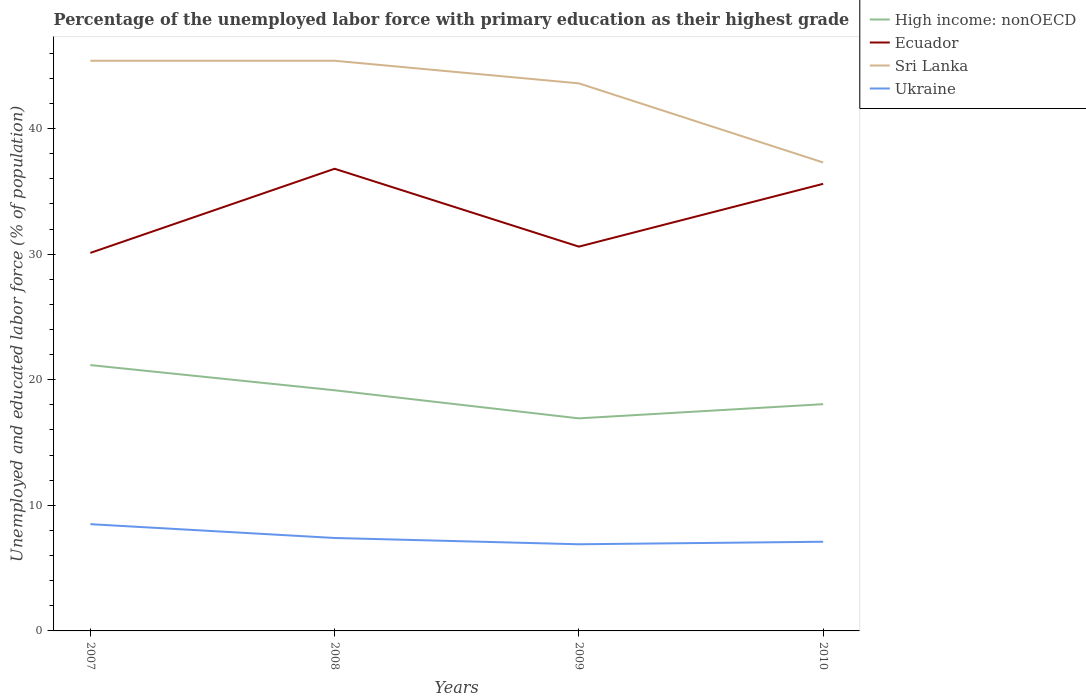How many different coloured lines are there?
Ensure brevity in your answer.  4. Does the line corresponding to Ecuador intersect with the line corresponding to Ukraine?
Offer a very short reply. No. Across all years, what is the maximum percentage of the unemployed labor force with primary education in Ukraine?
Keep it short and to the point. 6.9. What is the total percentage of the unemployed labor force with primary education in Ecuador in the graph?
Ensure brevity in your answer.  -5. What is the difference between the highest and the second highest percentage of the unemployed labor force with primary education in High income: nonOECD?
Make the answer very short. 4.24. Does the graph contain any zero values?
Make the answer very short. No. Does the graph contain grids?
Make the answer very short. No. Where does the legend appear in the graph?
Make the answer very short. Top right. What is the title of the graph?
Your response must be concise. Percentage of the unemployed labor force with primary education as their highest grade. What is the label or title of the Y-axis?
Your answer should be compact. Unemployed and educated labor force (% of population). What is the Unemployed and educated labor force (% of population) of High income: nonOECD in 2007?
Your answer should be compact. 21.17. What is the Unemployed and educated labor force (% of population) of Ecuador in 2007?
Your answer should be very brief. 30.1. What is the Unemployed and educated labor force (% of population) in Sri Lanka in 2007?
Your answer should be very brief. 45.4. What is the Unemployed and educated labor force (% of population) in High income: nonOECD in 2008?
Keep it short and to the point. 19.16. What is the Unemployed and educated labor force (% of population) in Ecuador in 2008?
Offer a very short reply. 36.8. What is the Unemployed and educated labor force (% of population) of Sri Lanka in 2008?
Provide a short and direct response. 45.4. What is the Unemployed and educated labor force (% of population) in Ukraine in 2008?
Provide a succinct answer. 7.4. What is the Unemployed and educated labor force (% of population) of High income: nonOECD in 2009?
Offer a terse response. 16.93. What is the Unemployed and educated labor force (% of population) of Ecuador in 2009?
Offer a very short reply. 30.6. What is the Unemployed and educated labor force (% of population) of Sri Lanka in 2009?
Your response must be concise. 43.6. What is the Unemployed and educated labor force (% of population) of Ukraine in 2009?
Provide a short and direct response. 6.9. What is the Unemployed and educated labor force (% of population) in High income: nonOECD in 2010?
Your response must be concise. 18.05. What is the Unemployed and educated labor force (% of population) in Ecuador in 2010?
Your answer should be compact. 35.6. What is the Unemployed and educated labor force (% of population) of Sri Lanka in 2010?
Give a very brief answer. 37.3. What is the Unemployed and educated labor force (% of population) in Ukraine in 2010?
Provide a short and direct response. 7.1. Across all years, what is the maximum Unemployed and educated labor force (% of population) in High income: nonOECD?
Keep it short and to the point. 21.17. Across all years, what is the maximum Unemployed and educated labor force (% of population) in Ecuador?
Give a very brief answer. 36.8. Across all years, what is the maximum Unemployed and educated labor force (% of population) of Sri Lanka?
Give a very brief answer. 45.4. Across all years, what is the maximum Unemployed and educated labor force (% of population) in Ukraine?
Offer a terse response. 8.5. Across all years, what is the minimum Unemployed and educated labor force (% of population) of High income: nonOECD?
Keep it short and to the point. 16.93. Across all years, what is the minimum Unemployed and educated labor force (% of population) of Ecuador?
Give a very brief answer. 30.1. Across all years, what is the minimum Unemployed and educated labor force (% of population) in Sri Lanka?
Your answer should be compact. 37.3. Across all years, what is the minimum Unemployed and educated labor force (% of population) of Ukraine?
Keep it short and to the point. 6.9. What is the total Unemployed and educated labor force (% of population) of High income: nonOECD in the graph?
Provide a short and direct response. 75.31. What is the total Unemployed and educated labor force (% of population) in Ecuador in the graph?
Give a very brief answer. 133.1. What is the total Unemployed and educated labor force (% of population) in Sri Lanka in the graph?
Offer a very short reply. 171.7. What is the total Unemployed and educated labor force (% of population) in Ukraine in the graph?
Your answer should be compact. 29.9. What is the difference between the Unemployed and educated labor force (% of population) in High income: nonOECD in 2007 and that in 2008?
Make the answer very short. 2.01. What is the difference between the Unemployed and educated labor force (% of population) of Sri Lanka in 2007 and that in 2008?
Your answer should be compact. 0. What is the difference between the Unemployed and educated labor force (% of population) in High income: nonOECD in 2007 and that in 2009?
Provide a short and direct response. 4.24. What is the difference between the Unemployed and educated labor force (% of population) of Ukraine in 2007 and that in 2009?
Ensure brevity in your answer.  1.6. What is the difference between the Unemployed and educated labor force (% of population) in High income: nonOECD in 2007 and that in 2010?
Give a very brief answer. 3.11. What is the difference between the Unemployed and educated labor force (% of population) of Sri Lanka in 2007 and that in 2010?
Ensure brevity in your answer.  8.1. What is the difference between the Unemployed and educated labor force (% of population) in Ukraine in 2007 and that in 2010?
Offer a very short reply. 1.4. What is the difference between the Unemployed and educated labor force (% of population) in High income: nonOECD in 2008 and that in 2009?
Give a very brief answer. 2.24. What is the difference between the Unemployed and educated labor force (% of population) of Sri Lanka in 2008 and that in 2009?
Provide a succinct answer. 1.8. What is the difference between the Unemployed and educated labor force (% of population) of High income: nonOECD in 2008 and that in 2010?
Provide a short and direct response. 1.11. What is the difference between the Unemployed and educated labor force (% of population) in Sri Lanka in 2008 and that in 2010?
Give a very brief answer. 8.1. What is the difference between the Unemployed and educated labor force (% of population) in Ukraine in 2008 and that in 2010?
Offer a terse response. 0.3. What is the difference between the Unemployed and educated labor force (% of population) in High income: nonOECD in 2009 and that in 2010?
Your response must be concise. -1.13. What is the difference between the Unemployed and educated labor force (% of population) in Sri Lanka in 2009 and that in 2010?
Provide a short and direct response. 6.3. What is the difference between the Unemployed and educated labor force (% of population) of High income: nonOECD in 2007 and the Unemployed and educated labor force (% of population) of Ecuador in 2008?
Offer a terse response. -15.63. What is the difference between the Unemployed and educated labor force (% of population) of High income: nonOECD in 2007 and the Unemployed and educated labor force (% of population) of Sri Lanka in 2008?
Offer a terse response. -24.23. What is the difference between the Unemployed and educated labor force (% of population) of High income: nonOECD in 2007 and the Unemployed and educated labor force (% of population) of Ukraine in 2008?
Ensure brevity in your answer.  13.77. What is the difference between the Unemployed and educated labor force (% of population) in Ecuador in 2007 and the Unemployed and educated labor force (% of population) in Sri Lanka in 2008?
Ensure brevity in your answer.  -15.3. What is the difference between the Unemployed and educated labor force (% of population) of Ecuador in 2007 and the Unemployed and educated labor force (% of population) of Ukraine in 2008?
Offer a very short reply. 22.7. What is the difference between the Unemployed and educated labor force (% of population) of Sri Lanka in 2007 and the Unemployed and educated labor force (% of population) of Ukraine in 2008?
Provide a succinct answer. 38. What is the difference between the Unemployed and educated labor force (% of population) in High income: nonOECD in 2007 and the Unemployed and educated labor force (% of population) in Ecuador in 2009?
Offer a terse response. -9.43. What is the difference between the Unemployed and educated labor force (% of population) of High income: nonOECD in 2007 and the Unemployed and educated labor force (% of population) of Sri Lanka in 2009?
Offer a very short reply. -22.43. What is the difference between the Unemployed and educated labor force (% of population) of High income: nonOECD in 2007 and the Unemployed and educated labor force (% of population) of Ukraine in 2009?
Your response must be concise. 14.27. What is the difference between the Unemployed and educated labor force (% of population) in Ecuador in 2007 and the Unemployed and educated labor force (% of population) in Ukraine in 2009?
Keep it short and to the point. 23.2. What is the difference between the Unemployed and educated labor force (% of population) in Sri Lanka in 2007 and the Unemployed and educated labor force (% of population) in Ukraine in 2009?
Your answer should be compact. 38.5. What is the difference between the Unemployed and educated labor force (% of population) in High income: nonOECD in 2007 and the Unemployed and educated labor force (% of population) in Ecuador in 2010?
Ensure brevity in your answer.  -14.43. What is the difference between the Unemployed and educated labor force (% of population) in High income: nonOECD in 2007 and the Unemployed and educated labor force (% of population) in Sri Lanka in 2010?
Offer a terse response. -16.13. What is the difference between the Unemployed and educated labor force (% of population) of High income: nonOECD in 2007 and the Unemployed and educated labor force (% of population) of Ukraine in 2010?
Your answer should be compact. 14.07. What is the difference between the Unemployed and educated labor force (% of population) of Sri Lanka in 2007 and the Unemployed and educated labor force (% of population) of Ukraine in 2010?
Offer a terse response. 38.3. What is the difference between the Unemployed and educated labor force (% of population) in High income: nonOECD in 2008 and the Unemployed and educated labor force (% of population) in Ecuador in 2009?
Your answer should be very brief. -11.44. What is the difference between the Unemployed and educated labor force (% of population) of High income: nonOECD in 2008 and the Unemployed and educated labor force (% of population) of Sri Lanka in 2009?
Offer a very short reply. -24.44. What is the difference between the Unemployed and educated labor force (% of population) of High income: nonOECD in 2008 and the Unemployed and educated labor force (% of population) of Ukraine in 2009?
Your response must be concise. 12.26. What is the difference between the Unemployed and educated labor force (% of population) of Ecuador in 2008 and the Unemployed and educated labor force (% of population) of Ukraine in 2009?
Provide a succinct answer. 29.9. What is the difference between the Unemployed and educated labor force (% of population) in Sri Lanka in 2008 and the Unemployed and educated labor force (% of population) in Ukraine in 2009?
Offer a terse response. 38.5. What is the difference between the Unemployed and educated labor force (% of population) in High income: nonOECD in 2008 and the Unemployed and educated labor force (% of population) in Ecuador in 2010?
Provide a short and direct response. -16.44. What is the difference between the Unemployed and educated labor force (% of population) in High income: nonOECD in 2008 and the Unemployed and educated labor force (% of population) in Sri Lanka in 2010?
Your response must be concise. -18.14. What is the difference between the Unemployed and educated labor force (% of population) in High income: nonOECD in 2008 and the Unemployed and educated labor force (% of population) in Ukraine in 2010?
Provide a succinct answer. 12.06. What is the difference between the Unemployed and educated labor force (% of population) in Ecuador in 2008 and the Unemployed and educated labor force (% of population) in Sri Lanka in 2010?
Provide a succinct answer. -0.5. What is the difference between the Unemployed and educated labor force (% of population) in Ecuador in 2008 and the Unemployed and educated labor force (% of population) in Ukraine in 2010?
Provide a short and direct response. 29.7. What is the difference between the Unemployed and educated labor force (% of population) in Sri Lanka in 2008 and the Unemployed and educated labor force (% of population) in Ukraine in 2010?
Your answer should be compact. 38.3. What is the difference between the Unemployed and educated labor force (% of population) of High income: nonOECD in 2009 and the Unemployed and educated labor force (% of population) of Ecuador in 2010?
Keep it short and to the point. -18.67. What is the difference between the Unemployed and educated labor force (% of population) of High income: nonOECD in 2009 and the Unemployed and educated labor force (% of population) of Sri Lanka in 2010?
Your answer should be very brief. -20.37. What is the difference between the Unemployed and educated labor force (% of population) in High income: nonOECD in 2009 and the Unemployed and educated labor force (% of population) in Ukraine in 2010?
Your answer should be compact. 9.83. What is the difference between the Unemployed and educated labor force (% of population) of Sri Lanka in 2009 and the Unemployed and educated labor force (% of population) of Ukraine in 2010?
Give a very brief answer. 36.5. What is the average Unemployed and educated labor force (% of population) in High income: nonOECD per year?
Make the answer very short. 18.83. What is the average Unemployed and educated labor force (% of population) of Ecuador per year?
Give a very brief answer. 33.27. What is the average Unemployed and educated labor force (% of population) of Sri Lanka per year?
Provide a succinct answer. 42.92. What is the average Unemployed and educated labor force (% of population) of Ukraine per year?
Keep it short and to the point. 7.47. In the year 2007, what is the difference between the Unemployed and educated labor force (% of population) in High income: nonOECD and Unemployed and educated labor force (% of population) in Ecuador?
Keep it short and to the point. -8.93. In the year 2007, what is the difference between the Unemployed and educated labor force (% of population) of High income: nonOECD and Unemployed and educated labor force (% of population) of Sri Lanka?
Give a very brief answer. -24.23. In the year 2007, what is the difference between the Unemployed and educated labor force (% of population) of High income: nonOECD and Unemployed and educated labor force (% of population) of Ukraine?
Make the answer very short. 12.67. In the year 2007, what is the difference between the Unemployed and educated labor force (% of population) in Ecuador and Unemployed and educated labor force (% of population) in Sri Lanka?
Ensure brevity in your answer.  -15.3. In the year 2007, what is the difference between the Unemployed and educated labor force (% of population) of Ecuador and Unemployed and educated labor force (% of population) of Ukraine?
Give a very brief answer. 21.6. In the year 2007, what is the difference between the Unemployed and educated labor force (% of population) of Sri Lanka and Unemployed and educated labor force (% of population) of Ukraine?
Provide a short and direct response. 36.9. In the year 2008, what is the difference between the Unemployed and educated labor force (% of population) of High income: nonOECD and Unemployed and educated labor force (% of population) of Ecuador?
Offer a very short reply. -17.64. In the year 2008, what is the difference between the Unemployed and educated labor force (% of population) of High income: nonOECD and Unemployed and educated labor force (% of population) of Sri Lanka?
Give a very brief answer. -26.24. In the year 2008, what is the difference between the Unemployed and educated labor force (% of population) of High income: nonOECD and Unemployed and educated labor force (% of population) of Ukraine?
Keep it short and to the point. 11.76. In the year 2008, what is the difference between the Unemployed and educated labor force (% of population) of Ecuador and Unemployed and educated labor force (% of population) of Ukraine?
Offer a very short reply. 29.4. In the year 2009, what is the difference between the Unemployed and educated labor force (% of population) in High income: nonOECD and Unemployed and educated labor force (% of population) in Ecuador?
Your answer should be compact. -13.67. In the year 2009, what is the difference between the Unemployed and educated labor force (% of population) in High income: nonOECD and Unemployed and educated labor force (% of population) in Sri Lanka?
Your response must be concise. -26.67. In the year 2009, what is the difference between the Unemployed and educated labor force (% of population) in High income: nonOECD and Unemployed and educated labor force (% of population) in Ukraine?
Keep it short and to the point. 10.03. In the year 2009, what is the difference between the Unemployed and educated labor force (% of population) of Ecuador and Unemployed and educated labor force (% of population) of Sri Lanka?
Give a very brief answer. -13. In the year 2009, what is the difference between the Unemployed and educated labor force (% of population) of Ecuador and Unemployed and educated labor force (% of population) of Ukraine?
Offer a terse response. 23.7. In the year 2009, what is the difference between the Unemployed and educated labor force (% of population) of Sri Lanka and Unemployed and educated labor force (% of population) of Ukraine?
Offer a very short reply. 36.7. In the year 2010, what is the difference between the Unemployed and educated labor force (% of population) in High income: nonOECD and Unemployed and educated labor force (% of population) in Ecuador?
Your answer should be very brief. -17.55. In the year 2010, what is the difference between the Unemployed and educated labor force (% of population) of High income: nonOECD and Unemployed and educated labor force (% of population) of Sri Lanka?
Keep it short and to the point. -19.25. In the year 2010, what is the difference between the Unemployed and educated labor force (% of population) in High income: nonOECD and Unemployed and educated labor force (% of population) in Ukraine?
Provide a succinct answer. 10.95. In the year 2010, what is the difference between the Unemployed and educated labor force (% of population) of Ecuador and Unemployed and educated labor force (% of population) of Sri Lanka?
Your answer should be compact. -1.7. In the year 2010, what is the difference between the Unemployed and educated labor force (% of population) of Ecuador and Unemployed and educated labor force (% of population) of Ukraine?
Keep it short and to the point. 28.5. In the year 2010, what is the difference between the Unemployed and educated labor force (% of population) in Sri Lanka and Unemployed and educated labor force (% of population) in Ukraine?
Provide a succinct answer. 30.2. What is the ratio of the Unemployed and educated labor force (% of population) of High income: nonOECD in 2007 to that in 2008?
Give a very brief answer. 1.1. What is the ratio of the Unemployed and educated labor force (% of population) in Ecuador in 2007 to that in 2008?
Your answer should be very brief. 0.82. What is the ratio of the Unemployed and educated labor force (% of population) of Sri Lanka in 2007 to that in 2008?
Your answer should be compact. 1. What is the ratio of the Unemployed and educated labor force (% of population) in Ukraine in 2007 to that in 2008?
Ensure brevity in your answer.  1.15. What is the ratio of the Unemployed and educated labor force (% of population) of High income: nonOECD in 2007 to that in 2009?
Offer a very short reply. 1.25. What is the ratio of the Unemployed and educated labor force (% of population) in Ecuador in 2007 to that in 2009?
Offer a very short reply. 0.98. What is the ratio of the Unemployed and educated labor force (% of population) of Sri Lanka in 2007 to that in 2009?
Your answer should be very brief. 1.04. What is the ratio of the Unemployed and educated labor force (% of population) of Ukraine in 2007 to that in 2009?
Give a very brief answer. 1.23. What is the ratio of the Unemployed and educated labor force (% of population) in High income: nonOECD in 2007 to that in 2010?
Offer a terse response. 1.17. What is the ratio of the Unemployed and educated labor force (% of population) of Ecuador in 2007 to that in 2010?
Your response must be concise. 0.85. What is the ratio of the Unemployed and educated labor force (% of population) of Sri Lanka in 2007 to that in 2010?
Offer a terse response. 1.22. What is the ratio of the Unemployed and educated labor force (% of population) of Ukraine in 2007 to that in 2010?
Offer a terse response. 1.2. What is the ratio of the Unemployed and educated labor force (% of population) in High income: nonOECD in 2008 to that in 2009?
Make the answer very short. 1.13. What is the ratio of the Unemployed and educated labor force (% of population) of Ecuador in 2008 to that in 2009?
Your response must be concise. 1.2. What is the ratio of the Unemployed and educated labor force (% of population) of Sri Lanka in 2008 to that in 2009?
Offer a terse response. 1.04. What is the ratio of the Unemployed and educated labor force (% of population) of Ukraine in 2008 to that in 2009?
Your answer should be very brief. 1.07. What is the ratio of the Unemployed and educated labor force (% of population) in High income: nonOECD in 2008 to that in 2010?
Provide a succinct answer. 1.06. What is the ratio of the Unemployed and educated labor force (% of population) of Ecuador in 2008 to that in 2010?
Provide a succinct answer. 1.03. What is the ratio of the Unemployed and educated labor force (% of population) in Sri Lanka in 2008 to that in 2010?
Offer a terse response. 1.22. What is the ratio of the Unemployed and educated labor force (% of population) in Ukraine in 2008 to that in 2010?
Offer a very short reply. 1.04. What is the ratio of the Unemployed and educated labor force (% of population) of High income: nonOECD in 2009 to that in 2010?
Keep it short and to the point. 0.94. What is the ratio of the Unemployed and educated labor force (% of population) in Ecuador in 2009 to that in 2010?
Provide a short and direct response. 0.86. What is the ratio of the Unemployed and educated labor force (% of population) in Sri Lanka in 2009 to that in 2010?
Your answer should be compact. 1.17. What is the ratio of the Unemployed and educated labor force (% of population) of Ukraine in 2009 to that in 2010?
Offer a very short reply. 0.97. What is the difference between the highest and the second highest Unemployed and educated labor force (% of population) in High income: nonOECD?
Your response must be concise. 2.01. What is the difference between the highest and the second highest Unemployed and educated labor force (% of population) in Sri Lanka?
Keep it short and to the point. 0. What is the difference between the highest and the second highest Unemployed and educated labor force (% of population) in Ukraine?
Make the answer very short. 1.1. What is the difference between the highest and the lowest Unemployed and educated labor force (% of population) of High income: nonOECD?
Offer a terse response. 4.24. What is the difference between the highest and the lowest Unemployed and educated labor force (% of population) of Ecuador?
Offer a very short reply. 6.7. What is the difference between the highest and the lowest Unemployed and educated labor force (% of population) of Ukraine?
Provide a succinct answer. 1.6. 